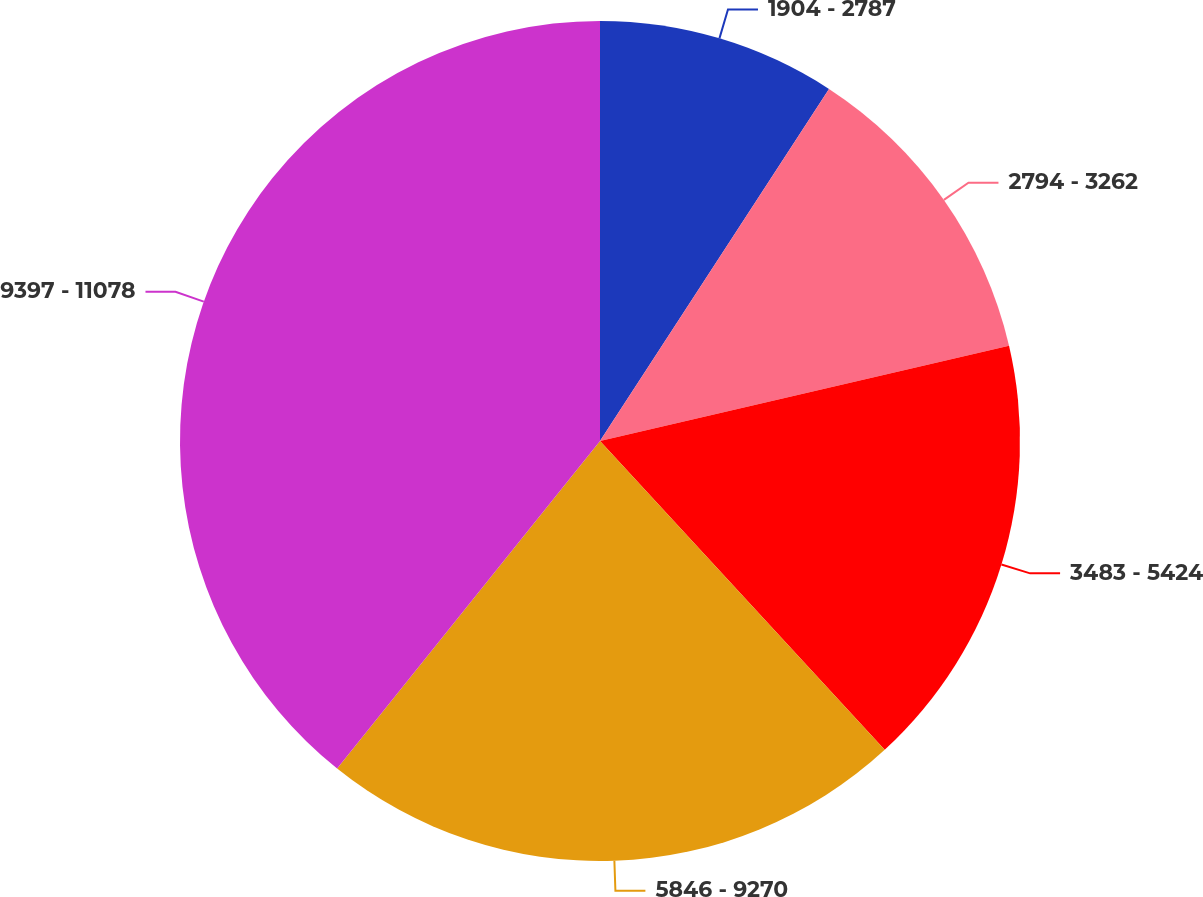Convert chart to OTSL. <chart><loc_0><loc_0><loc_500><loc_500><pie_chart><fcel>1904 - 2787<fcel>2794 - 3262<fcel>3483 - 5424<fcel>5846 - 9270<fcel>9397 - 11078<nl><fcel>9.18%<fcel>12.18%<fcel>16.79%<fcel>22.62%<fcel>39.24%<nl></chart> 